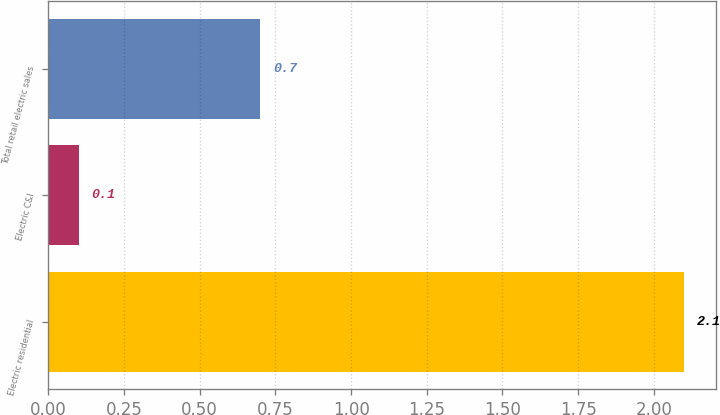Convert chart. <chart><loc_0><loc_0><loc_500><loc_500><bar_chart><fcel>Electric residential<fcel>Electric C&I<fcel>Total retail electric sales<nl><fcel>2.1<fcel>0.1<fcel>0.7<nl></chart> 